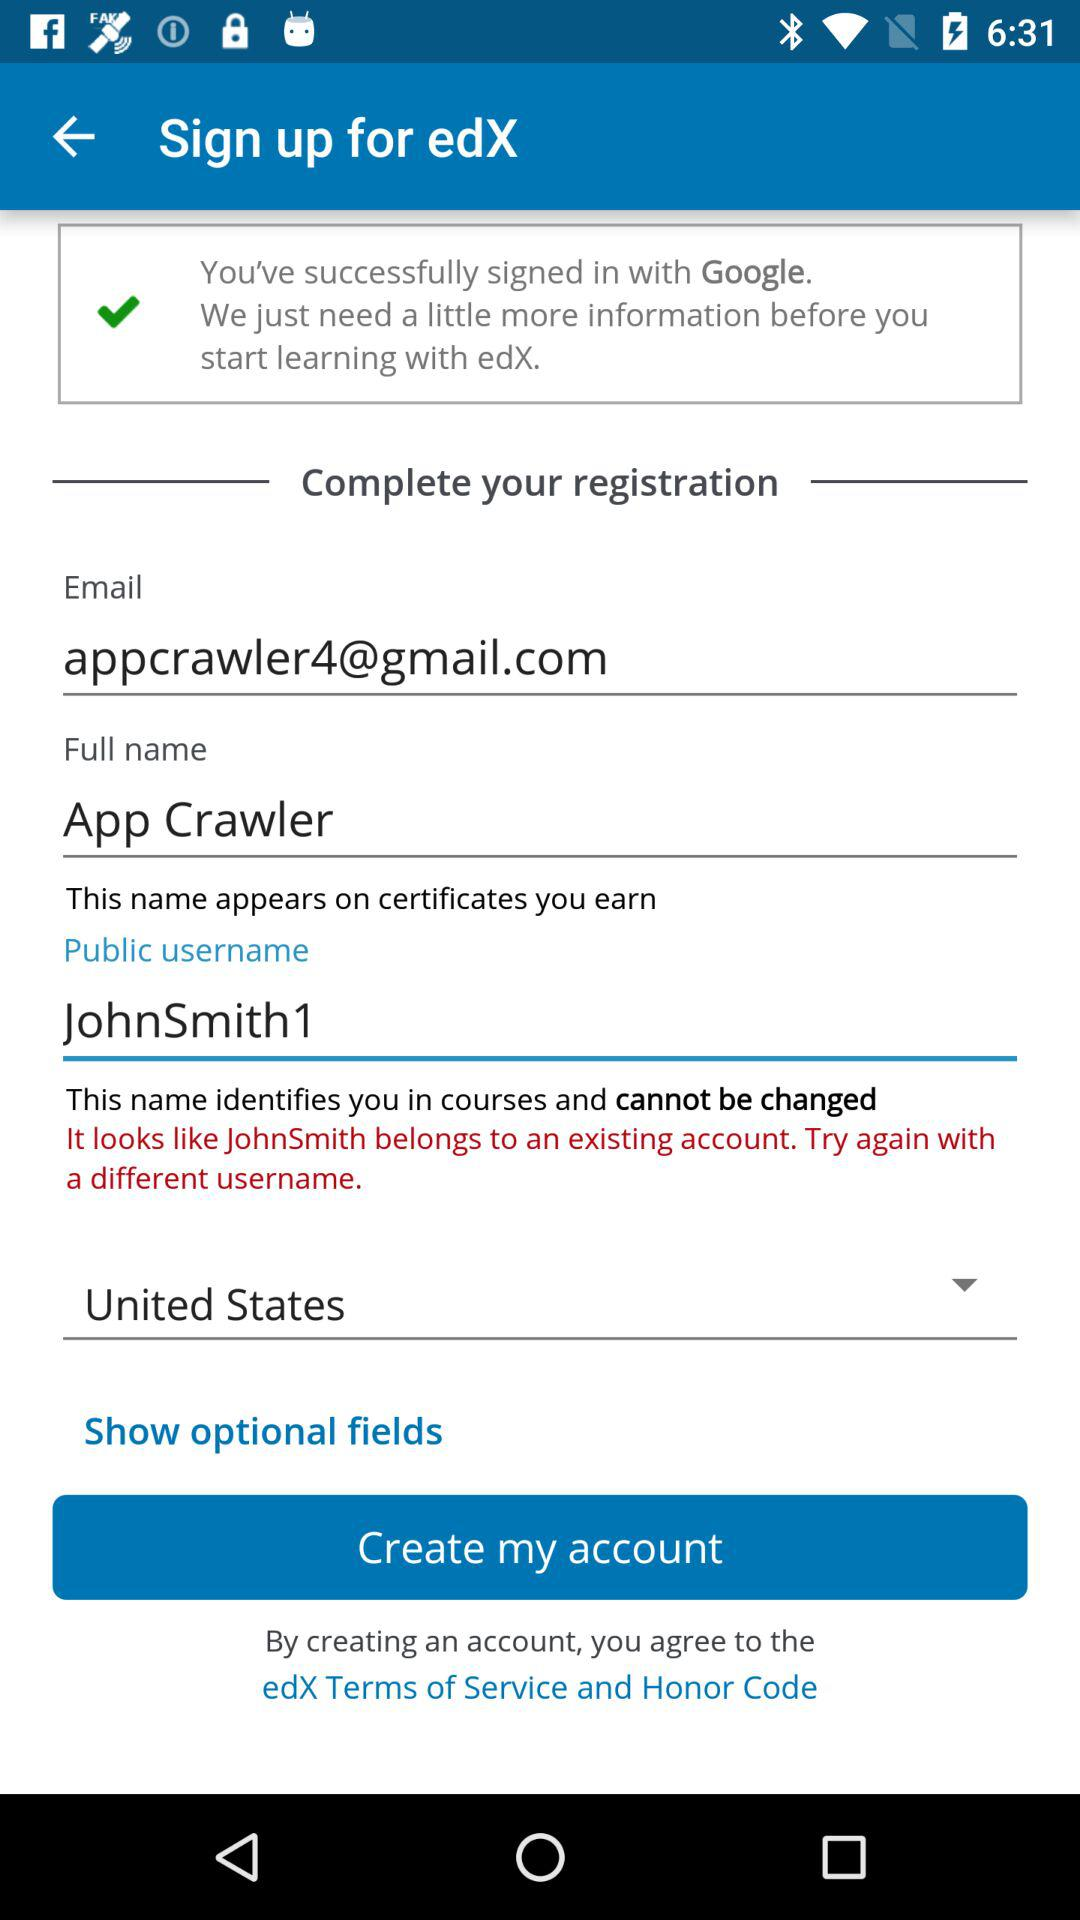Which country is selected? The selected country is the United States. 